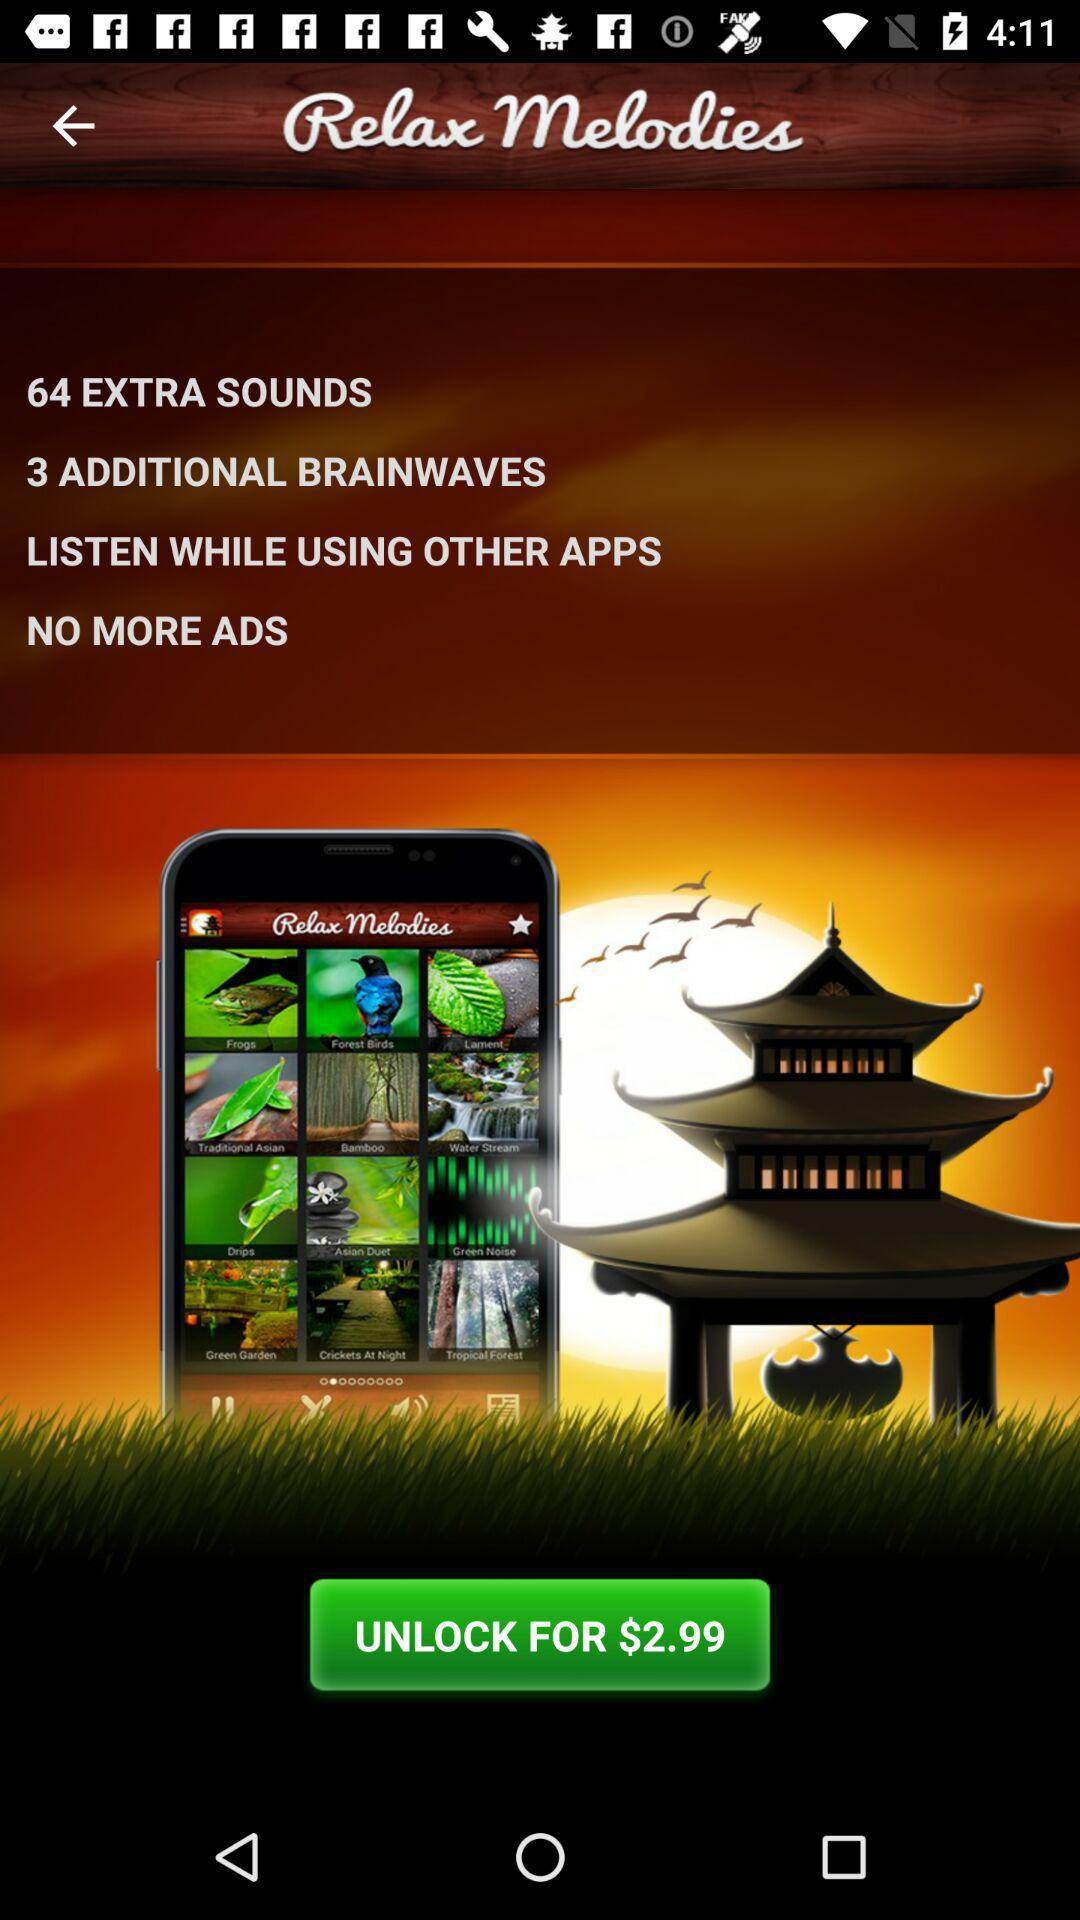What is the price for unlocking the melodies? The price is $2.99. 